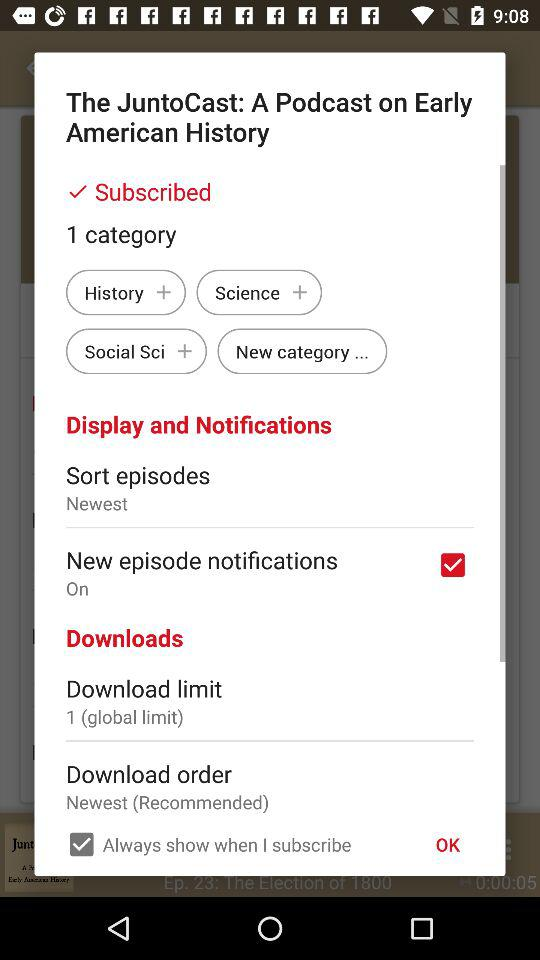How many categories are there for The JuntoCast?
Answer the question using a single word or phrase. 1 